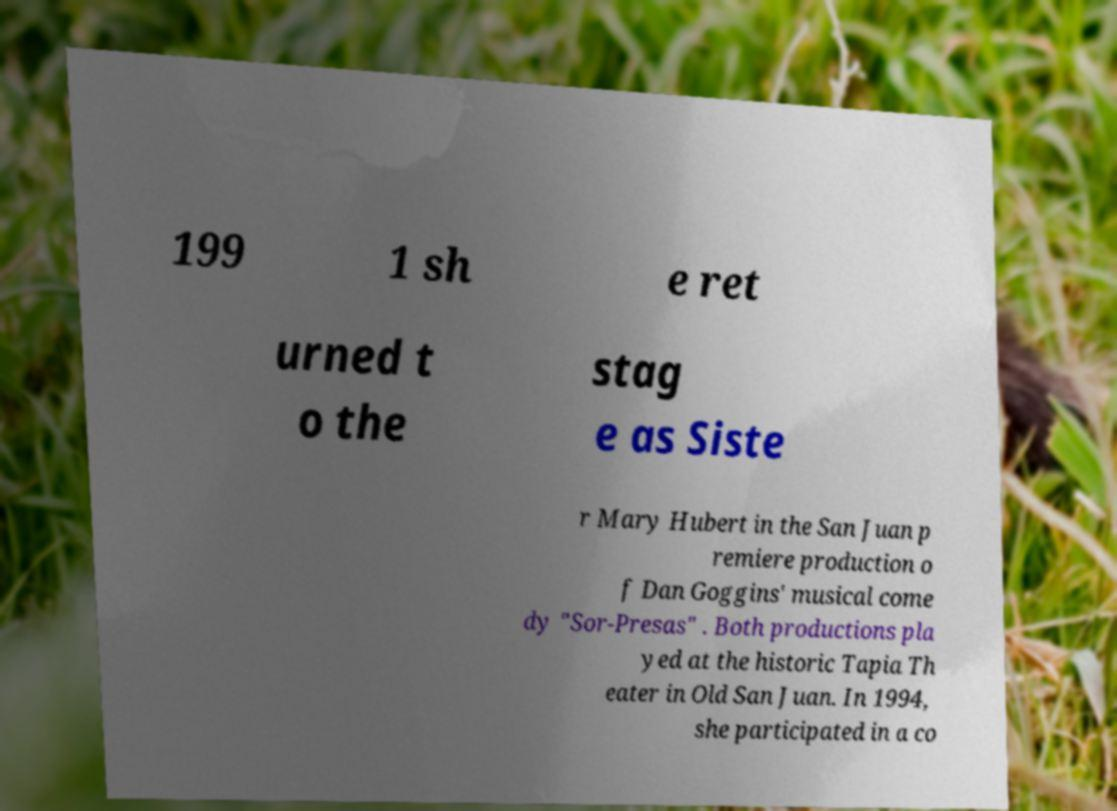What messages or text are displayed in this image? I need them in a readable, typed format. 199 1 sh e ret urned t o the stag e as Siste r Mary Hubert in the San Juan p remiere production o f Dan Goggins' musical come dy "Sor-Presas" . Both productions pla yed at the historic Tapia Th eater in Old San Juan. In 1994, she participated in a co 